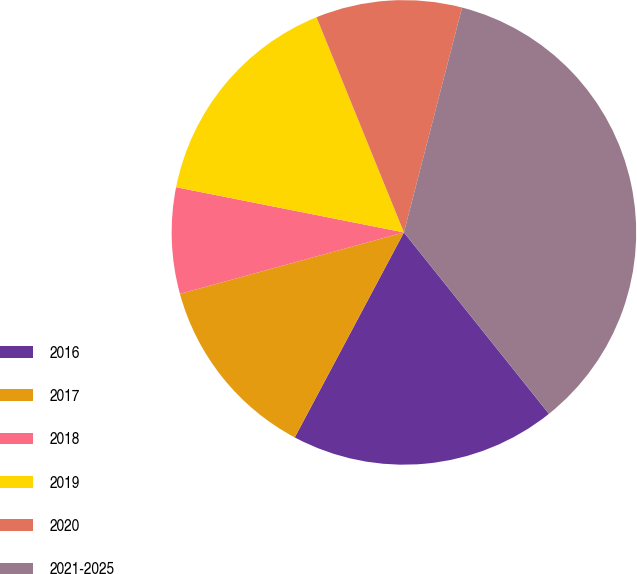Convert chart. <chart><loc_0><loc_0><loc_500><loc_500><pie_chart><fcel>2016<fcel>2017<fcel>2018<fcel>2019<fcel>2020<fcel>2021-2025<nl><fcel>18.52%<fcel>12.95%<fcel>7.38%<fcel>15.74%<fcel>10.17%<fcel>35.24%<nl></chart> 